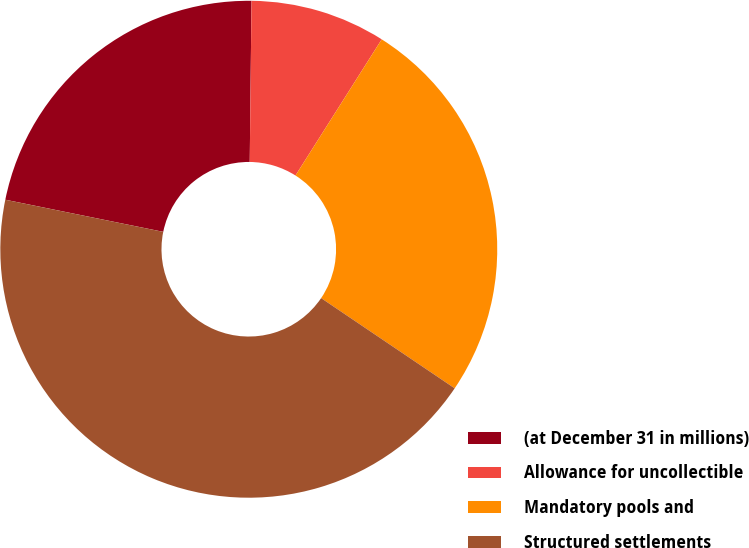Convert chart. <chart><loc_0><loc_0><loc_500><loc_500><pie_chart><fcel>(at December 31 in millions)<fcel>Allowance for uncollectible<fcel>Mandatory pools and<fcel>Structured settlements<nl><fcel>21.98%<fcel>8.81%<fcel>25.47%<fcel>43.74%<nl></chart> 